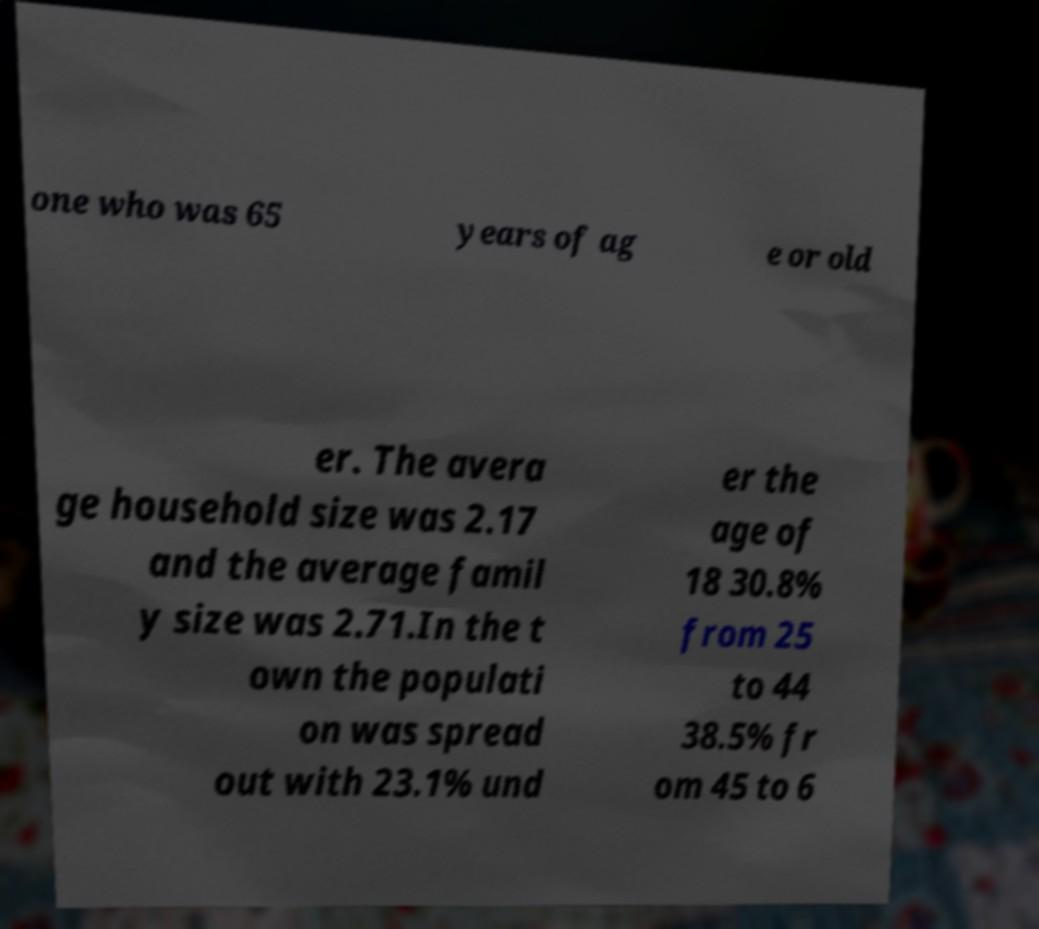There's text embedded in this image that I need extracted. Can you transcribe it verbatim? one who was 65 years of ag e or old er. The avera ge household size was 2.17 and the average famil y size was 2.71.In the t own the populati on was spread out with 23.1% und er the age of 18 30.8% from 25 to 44 38.5% fr om 45 to 6 